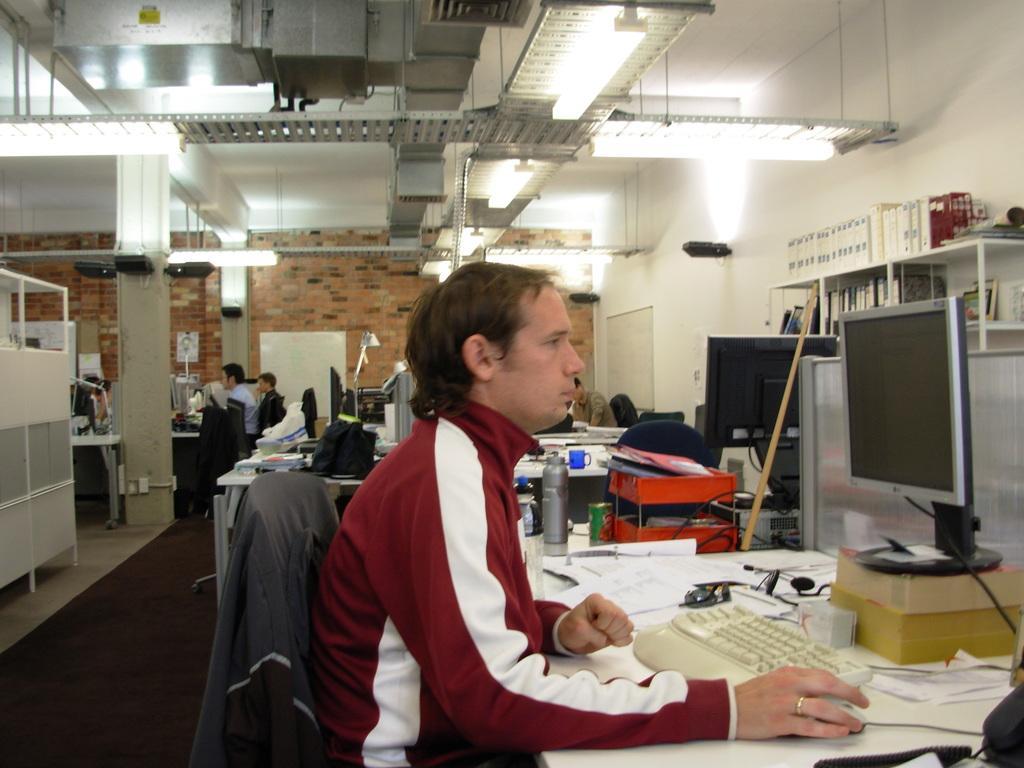Please provide a concise description of this image. In this image we can see a person sitting on a chair holding a mouse near a table containing a laptop, keyboard, papers, cup, box and a bottle. On the backside we can see some people sitting. We can also see a wall, ceiling lights, a roof, floor, cupboard and some books in the shelves. 